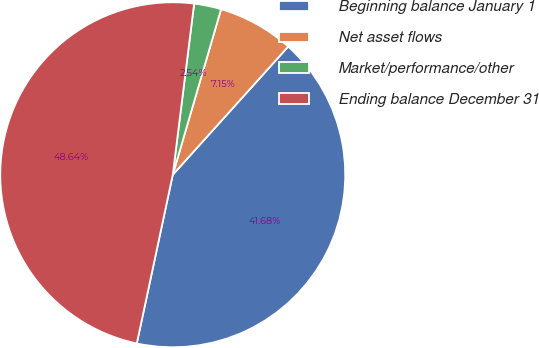Convert chart. <chart><loc_0><loc_0><loc_500><loc_500><pie_chart><fcel>Beginning balance January 1<fcel>Net asset flows<fcel>Market/performance/other<fcel>Ending balance December 31<nl><fcel>41.68%<fcel>7.15%<fcel>2.54%<fcel>48.64%<nl></chart> 